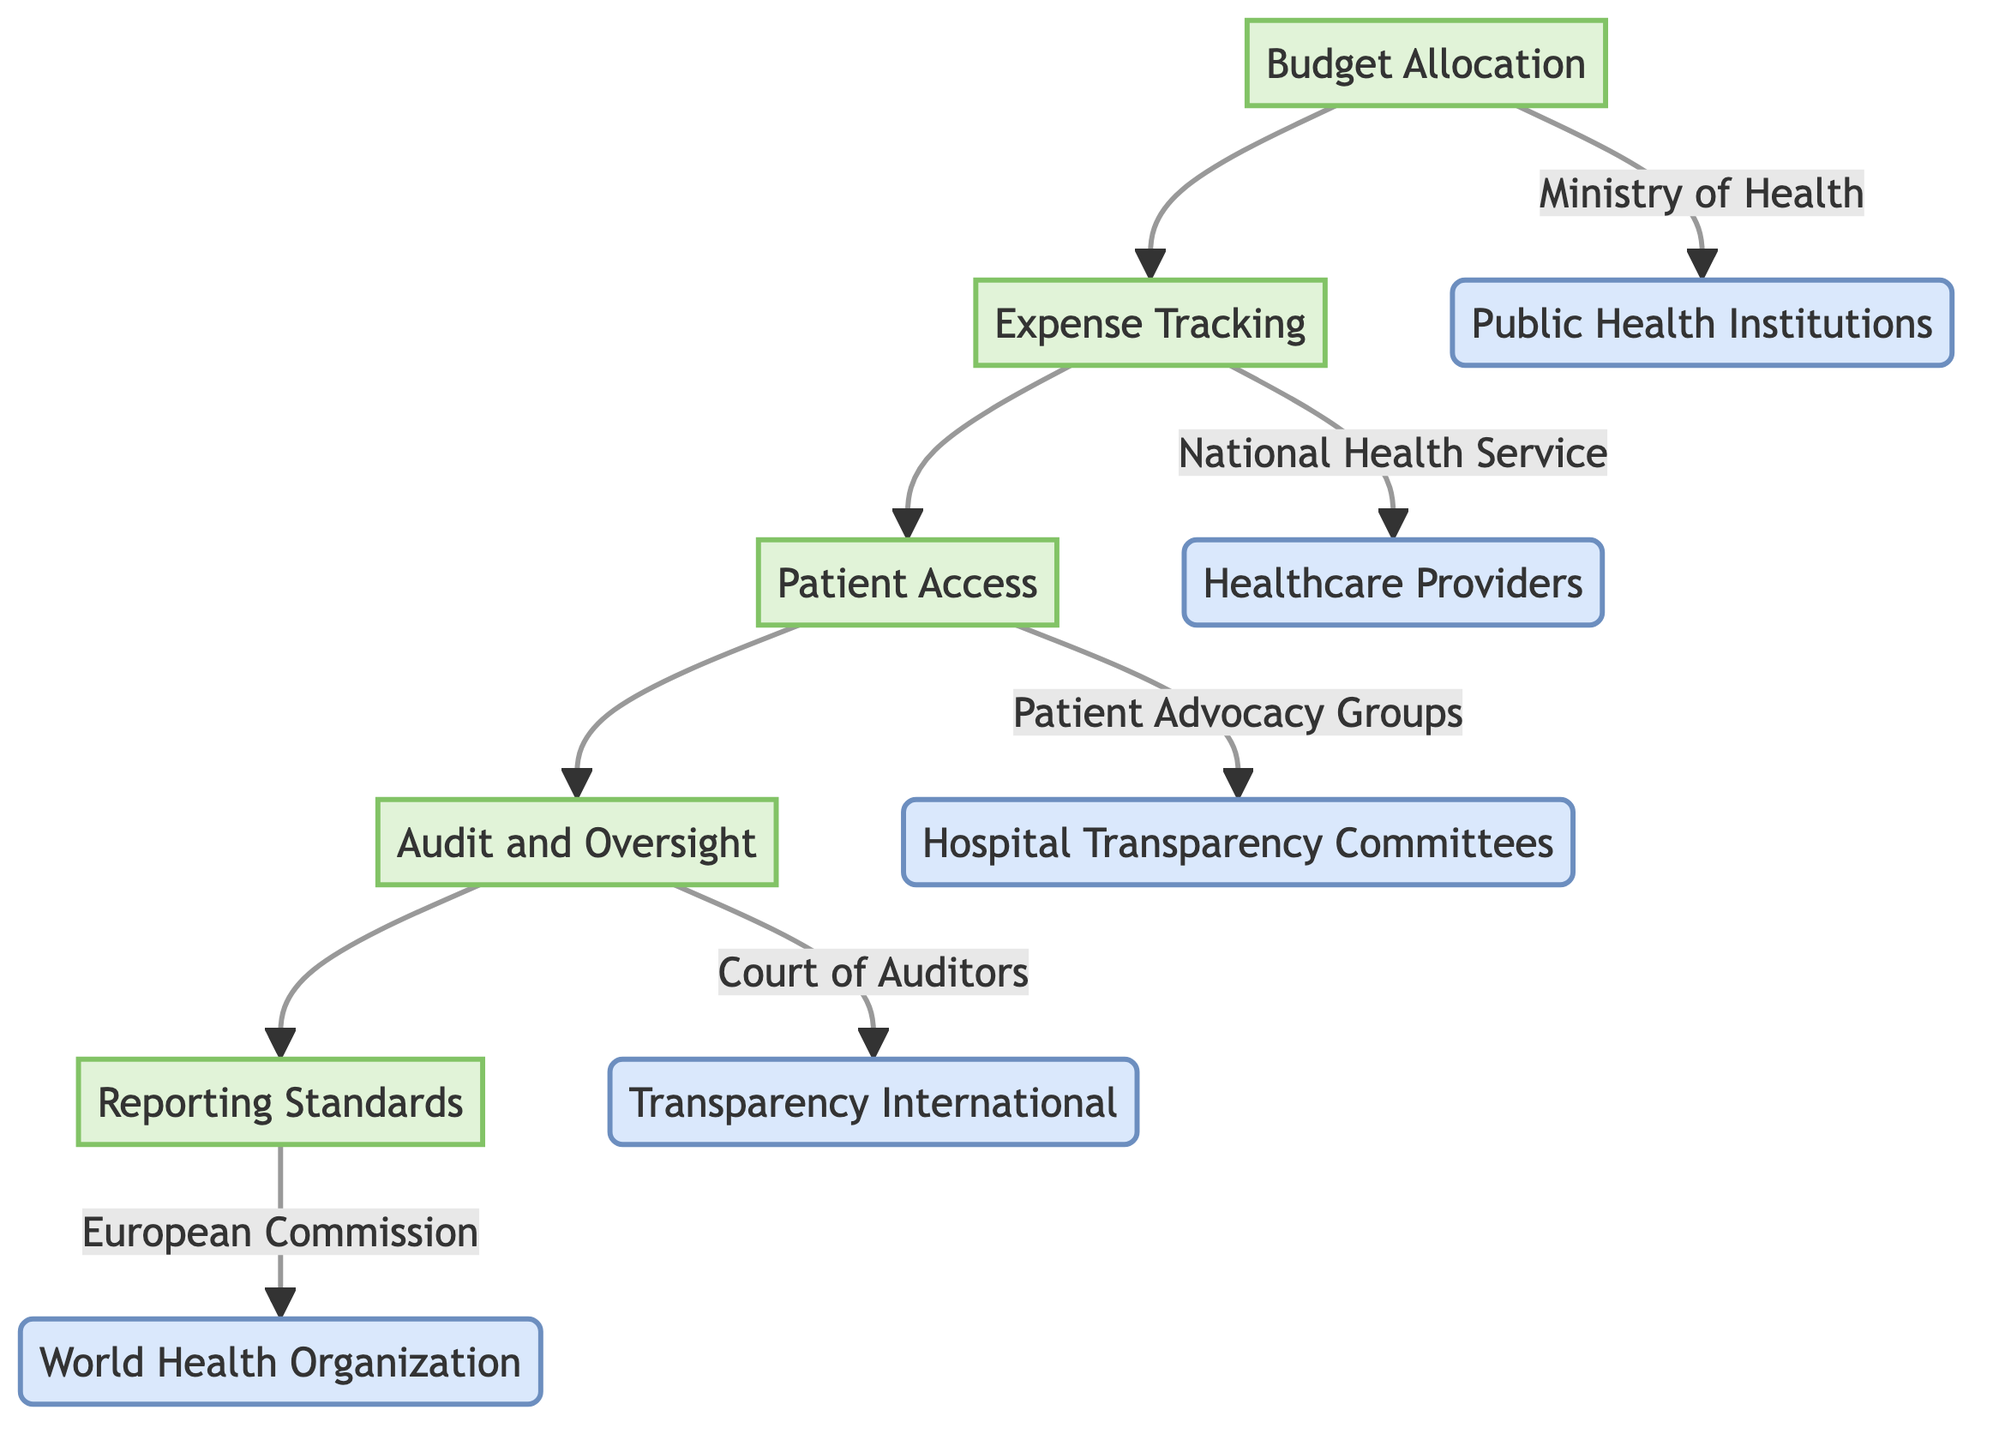What are the main components of the clinical pathway? The clinical pathway consists of five main components: Budget Allocation, Expense Tracking, Patient Access, Audit and Oversight, and Reporting Standards.
Answer: Budget Allocation, Expense Tracking, Patient Access, Audit and Oversight, Reporting Standards Which entity is responsible for Budget Allocation? According to the diagram, the Ministry of Health is the entity responsible for Budget Allocation.
Answer: Ministry of Health How many entities are linked to Expense Tracking? There are two entities linked to Expense Tracking: the National Health Service and Healthcare Providers. Counting them gives a total of two.
Answer: 2 What comes after Patient Access in the pathway? The next element after Patient Access in the pathway is Audit and Oversight, as indicated by the directional flow from Patient Access to Audit and Oversight.
Answer: Audit and Oversight Which organization contributes to Reporting Standards? The European Commission is the organization that contributes to Reporting Standards, as shown in the diagram.
Answer: European Commission What is the relationship between Budget Allocation and Public Health Institutions? The diagram shows a direct link from Budget Allocation to Public Health Institutions, indicating that they are influenced by or receive funds from Budget Allocation.
Answer: Public Health Institutions Name one group involved in Patient Access. One group involved in Patient Access is the Patient Advocacy Groups, as identified in the diagram.
Answer: Patient Advocacy Groups Which component involves regular reviews of fund usage? Audit and Oversight involves regular reviews to ensure proper use of funds, as stated in the description of that component in the diagram.
Answer: Audit and Oversight What is the final step in this clinical pathway? The final step in the clinical pathway is Reporting Standards, as it is the last component in the flow of the diagram.
Answer: Reporting Standards 